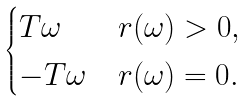<formula> <loc_0><loc_0><loc_500><loc_500>\begin{cases} T \omega & \text {$r (\omega) > 0$} , \\ - T \omega & \text {$r (\omega) = 0$} . \end{cases}</formula> 